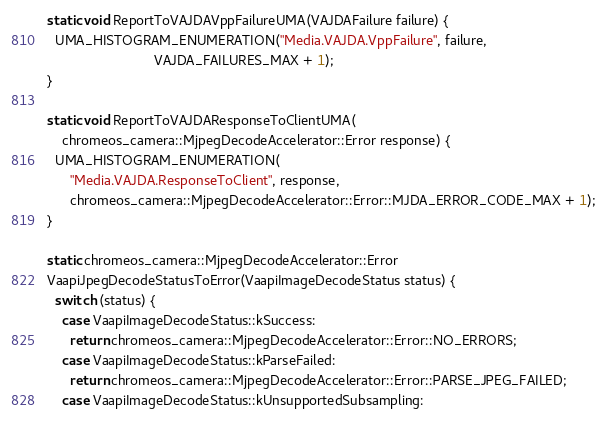<code> <loc_0><loc_0><loc_500><loc_500><_C++_>static void ReportToVAJDAVppFailureUMA(VAJDAFailure failure) {
  UMA_HISTOGRAM_ENUMERATION("Media.VAJDA.VppFailure", failure,
                            VAJDA_FAILURES_MAX + 1);
}

static void ReportToVAJDAResponseToClientUMA(
    chromeos_camera::MjpegDecodeAccelerator::Error response) {
  UMA_HISTOGRAM_ENUMERATION(
      "Media.VAJDA.ResponseToClient", response,
      chromeos_camera::MjpegDecodeAccelerator::Error::MJDA_ERROR_CODE_MAX + 1);
}

static chromeos_camera::MjpegDecodeAccelerator::Error
VaapiJpegDecodeStatusToError(VaapiImageDecodeStatus status) {
  switch (status) {
    case VaapiImageDecodeStatus::kSuccess:
      return chromeos_camera::MjpegDecodeAccelerator::Error::NO_ERRORS;
    case VaapiImageDecodeStatus::kParseFailed:
      return chromeos_camera::MjpegDecodeAccelerator::Error::PARSE_JPEG_FAILED;
    case VaapiImageDecodeStatus::kUnsupportedSubsampling:</code> 